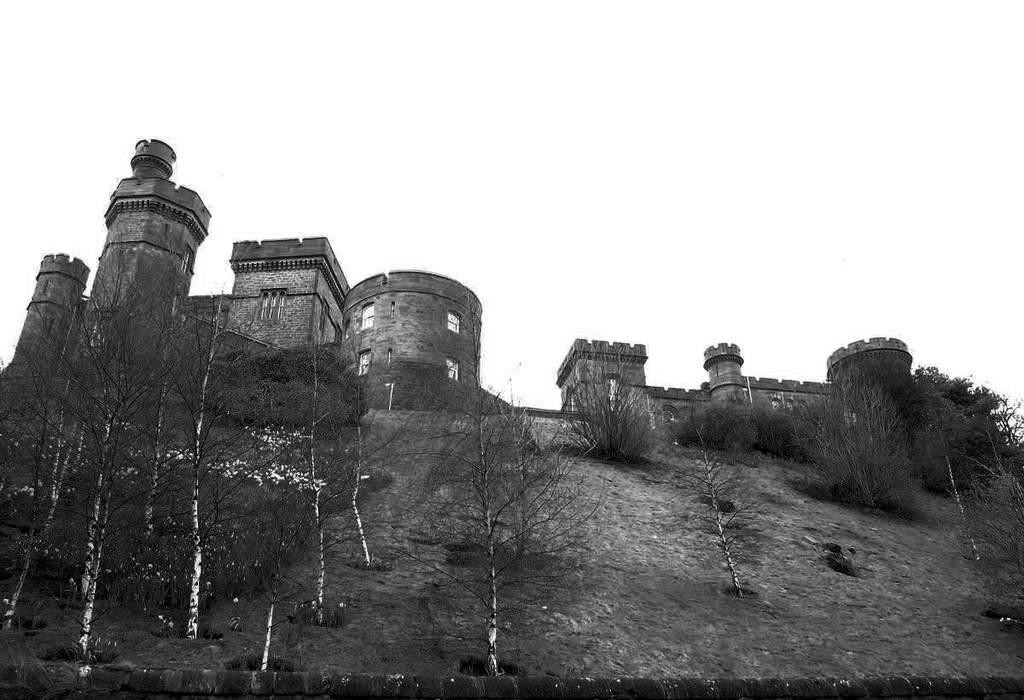What type of picture is in the image? The image contains a black and white picture. What structures can be seen in the picture? There are buildings in the picture. What type of vegetation is present in the picture? There are trees in the picture. What part of the natural environment is visible in the picture? The sky is visible in the picture. What type of jeans is the tree wearing in the image? There are no jeans present in the image, as trees do not wear clothing. 